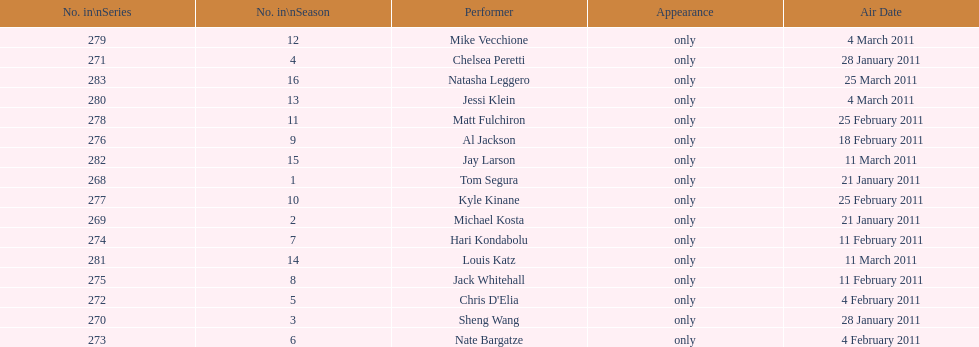How many performers appeared on the air date 21 january 2011? 2. 